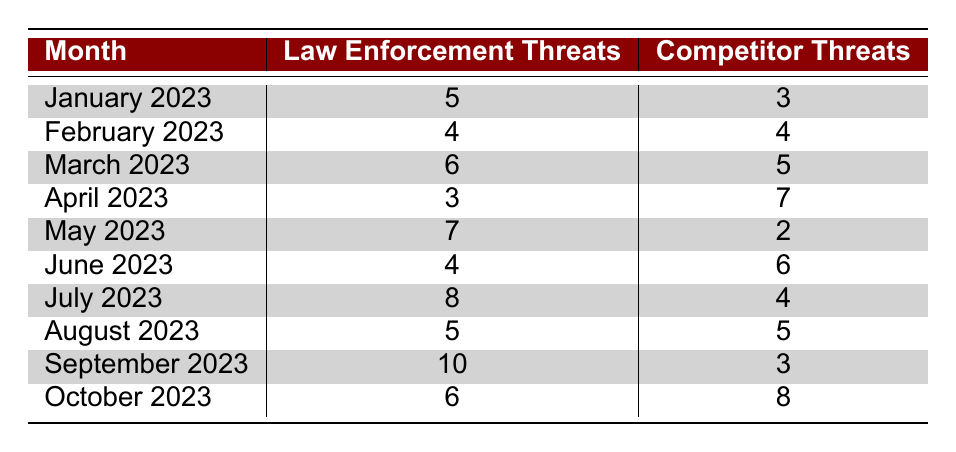What month had the highest number of law enforcement threats? The table indicates that September 2023 had the highest number of law enforcement threats, which is 10.
Answer: September 2023 What was the total number of competitor threats in April and May 2023 combined? The competitor threats in April 2023 were 7, and in May 2023, they were 2. Adding these gives 7 + 2 = 9.
Answer: 9 Was there any month where the number of law enforcement threats exceeded competitor threats? Yes, in March 2023, there were 6 law enforcement threats and 5 competitor threats. This indicates that law enforcement threats exceeded competitor threats during this month.
Answer: Yes What is the average number of law enforcement threats across all months represented in the table? The sum of law enforcement threats over the months is 5 + 4 + 6 + 3 + 7 + 4 + 8 + 5 + 10 + 6 = 58. There are 10 months, so the average is 58 / 10 = 5.8.
Answer: 5.8 In which month did competitor threats reach their peak? The competitor threats peaked in April 2023 with a total of 7 threats, which is the highest recorded for any month.
Answer: April 2023 How many total threats (law enforcement and competitor) were recorded in August 2023? In August 2023, there were 5 law enforcement threats and 5 competitor threats. The total is 5 + 5 = 10.
Answer: 10 Was there a month when law enforcement threats were exactly equal to competitor threats? Yes, there were two months (February 2023 and August 2023) where law enforcement threats equaled competitor threats, both having 4 and 5 respectively.
Answer: Yes Which month had the least law enforcement threats? April 2023 had the least law enforcement threats recorded at 3.
Answer: April 2023 In September 2023, how many more law enforcement threats were there than competitor threats? In September 2023, there were 10 law enforcement threats and 3 competitor threats. The difference is 10 - 3 = 7.
Answer: 7 